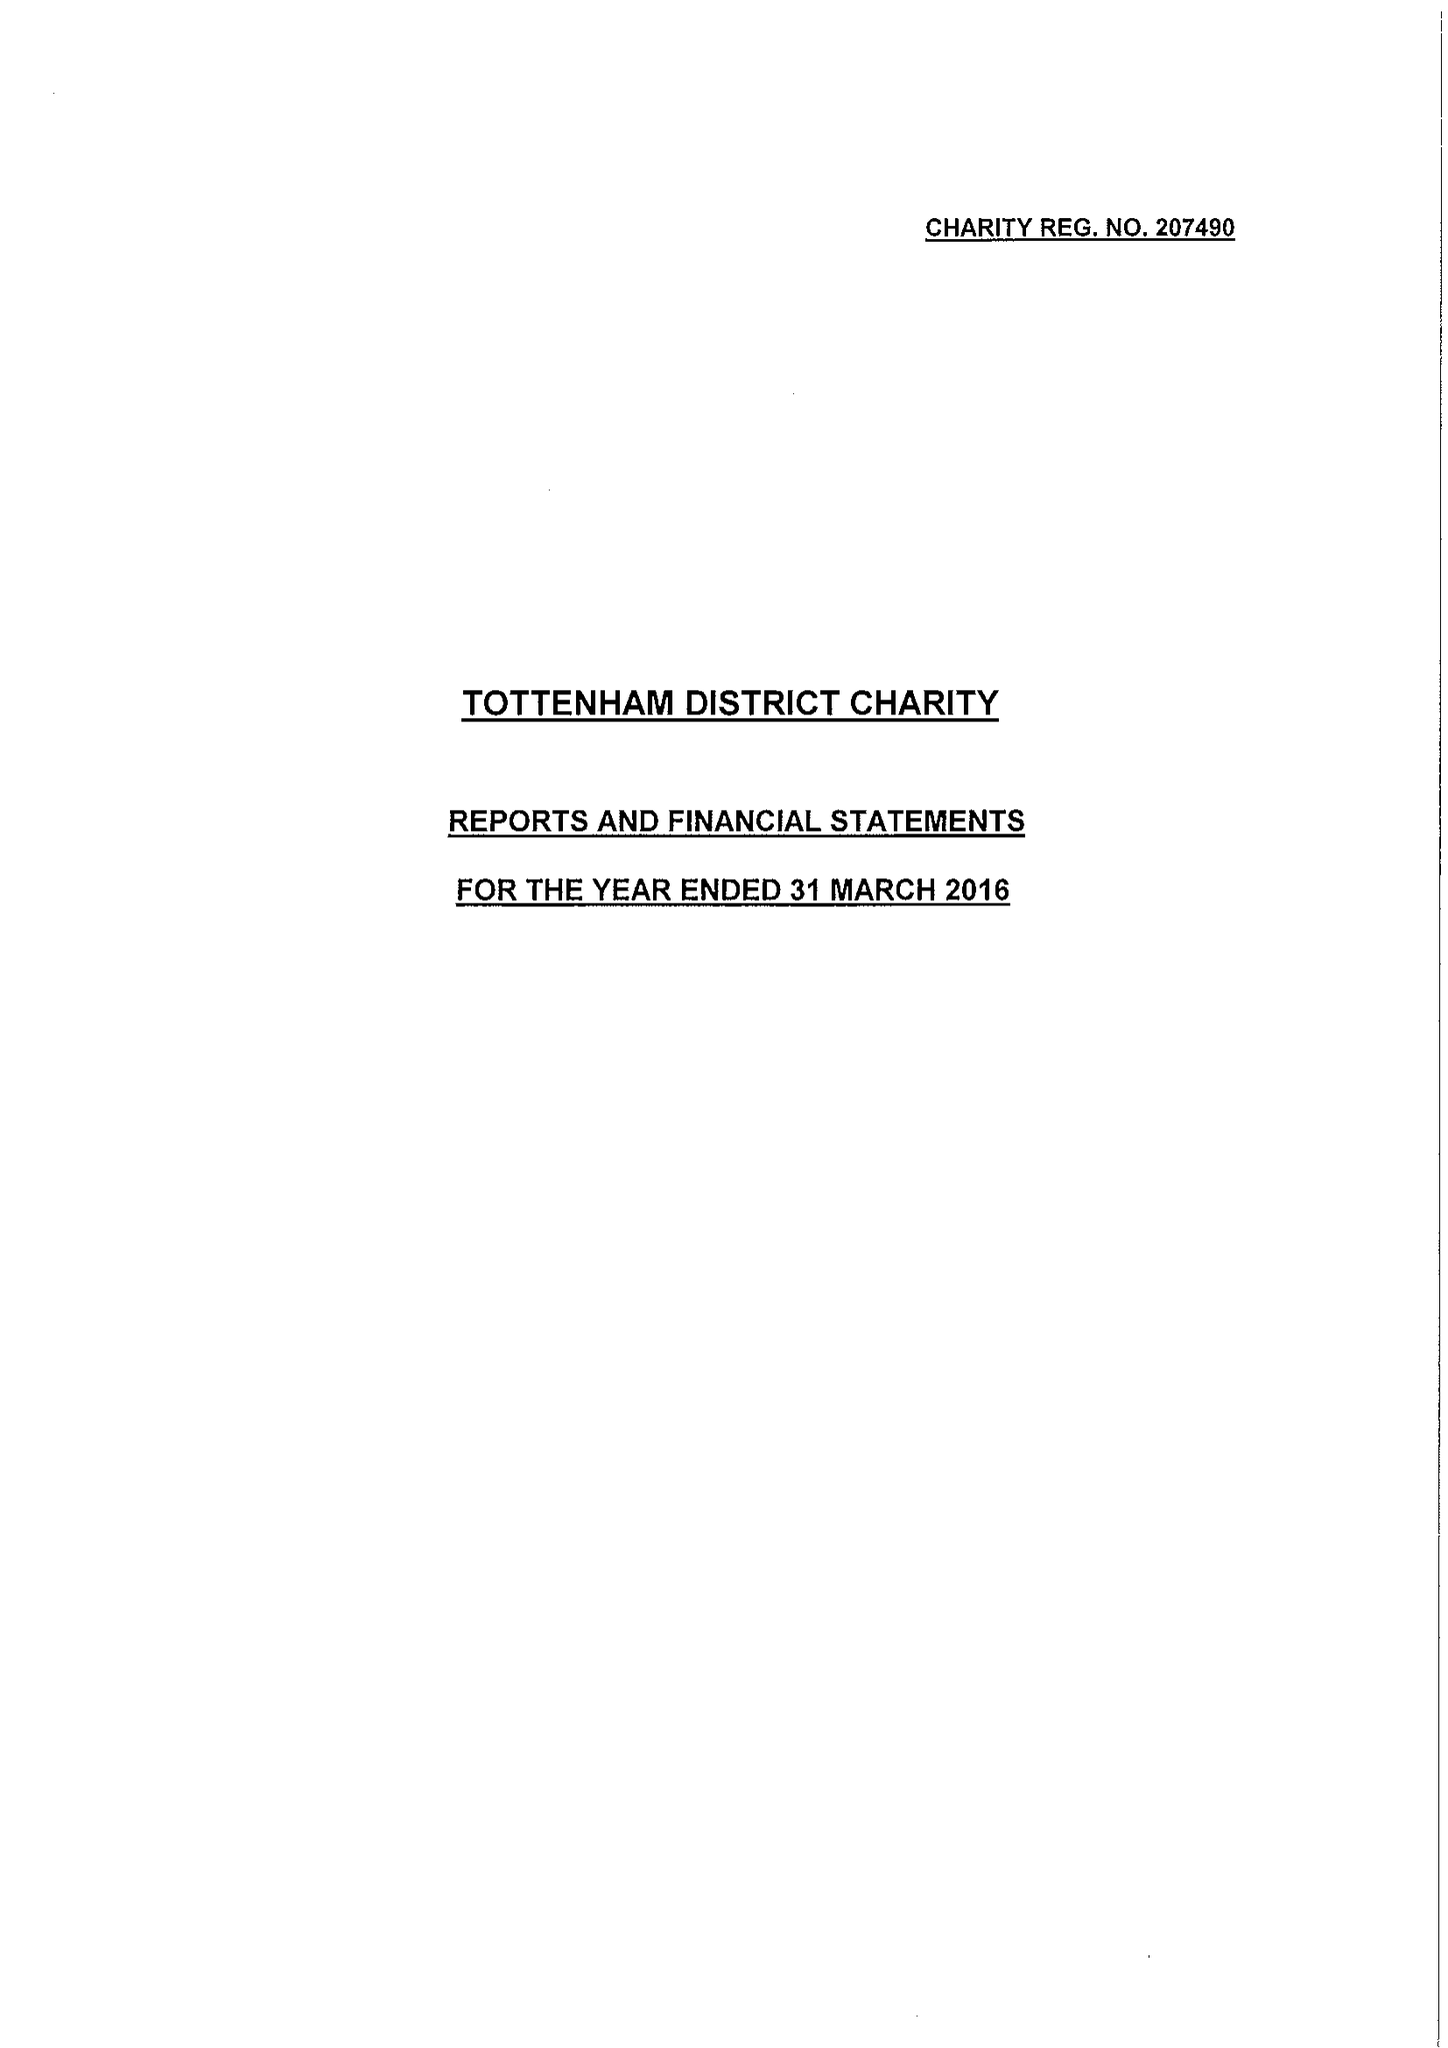What is the value for the income_annually_in_british_pounds?
Answer the question using a single word or phrase. 112847.00 